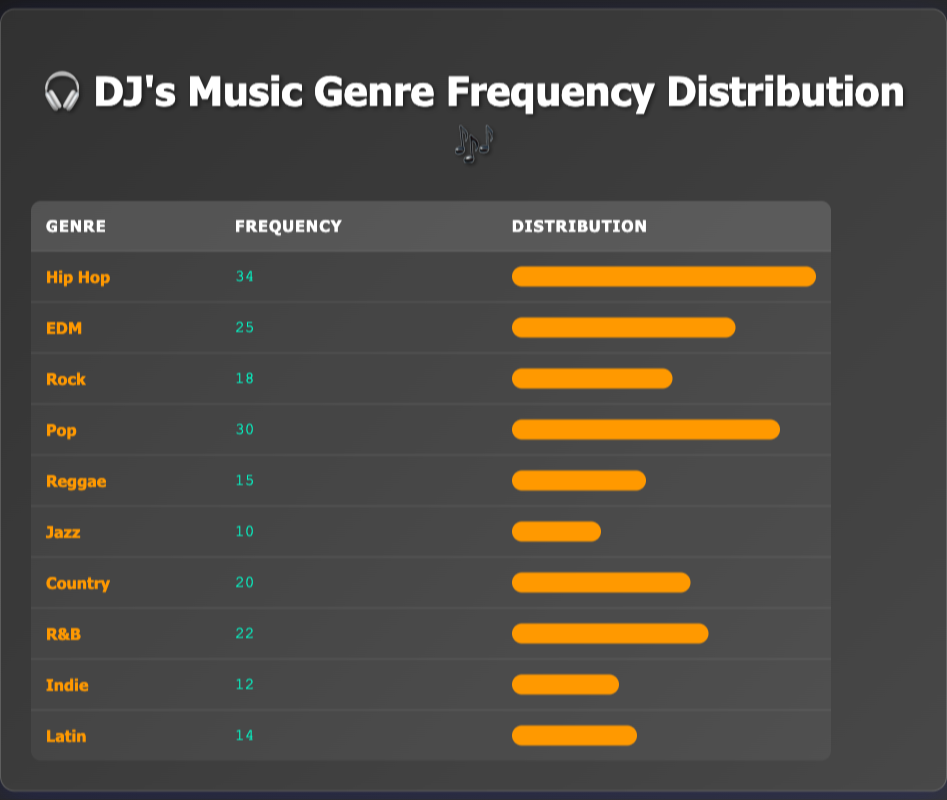What genre had the highest frequency of requests? By examining the frequency values in the table, the genre with the highest frequency is "Hip Hop," with a count of 34 requests.
Answer: Hip Hop How many requests were made for Pop and R&B combined? To get the total requests for Pop and R&B, I need to add their frequencies: Pop (30) + R&B (22) = 52.
Answer: 52 Is the frequency of requests for Jazz greater than that for Reggae? From the table, Jazz has a frequency of 10 requests, while Reggae has 15 requests. Since 10 is less than 15, the statement is false.
Answer: No What is the total number of requests for all music genres? I will sum the frequencies of all genres: 34 (Hip Hop) + 25 (EDM) + 18 (Rock) + 30 (Pop) + 15 (Reggae) + 10 (Jazz) + 20 (Country) + 22 (R&B) + 12 (Indie) + 14 (Latin) =  34 + 25 + 18 + 30 + 15 + 10 + 20 + 22 + 12 + 14 =  210 requests in total.
Answer: 210 Which genre had the lowest frequency, and what was that frequency? From the table, Jazz has the lowest frequency with a total of 10 requests.
Answer: Jazz, 10 How does the frequency of EDM compare to that of Country? The frequency for EDM is 25, while Country has a frequency of 20. Thus, EDM exceeds Country by 5 requests.
Answer: EDM is greater by 5 